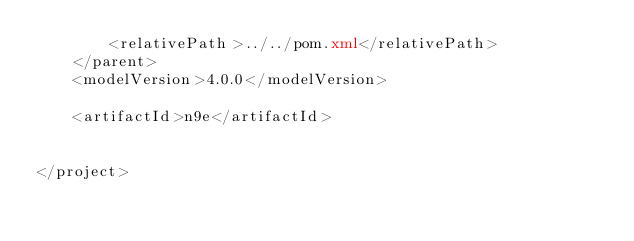Convert code to text. <code><loc_0><loc_0><loc_500><loc_500><_XML_>        <relativePath>../../pom.xml</relativePath>
    </parent>
    <modelVersion>4.0.0</modelVersion>

    <artifactId>n9e</artifactId>


</project></code> 